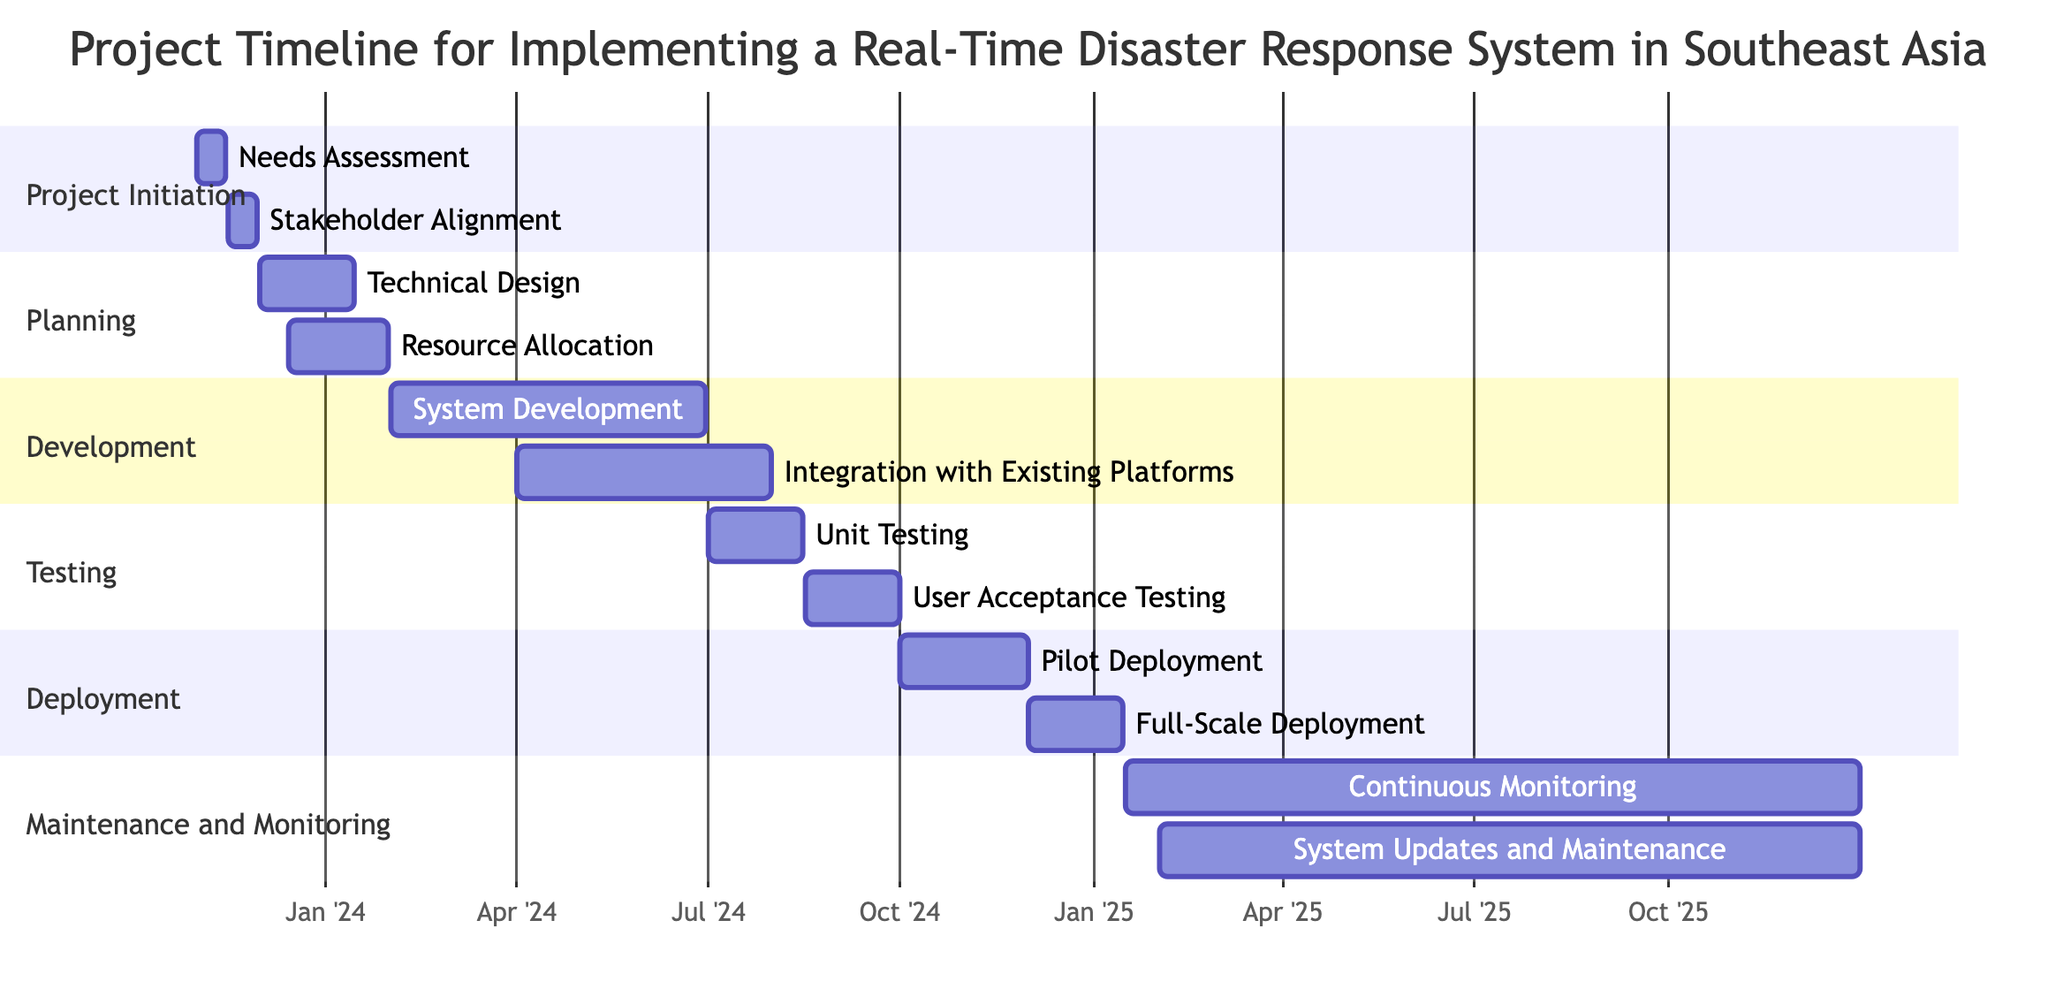What are the start and end dates for the "Needs Assessment" task? The "Needs Assessment" task starts on 2023-11-01 and ends on 2023-11-15, which can be directly identified in the diagram's "Project Initiation" section.
Answer: 2023-11-01 to 2023-11-15 How many tasks are there in the "Development" phase? The "Development" phase contains two tasks: "System Development" and "Integration with Existing Platforms," as shown in the corresponding section of the diagram.
Answer: 2 What is the duration of the "User Acceptance Testing" task? The "User Acceptance Testing" task starts on 2024-08-16 and ends on 2024-09-30. The duration can be calculated as the difference between these two dates, which is 1 month and 14 days, but is also visible directly on the Gantt chart itself.
Answer: 1 month and 14 days Which task overlaps with the "System Development" task? The "Integration with Existing Platforms" task overlaps with "System Development" since it starts on 2024-04-01 while "System Development" is still ongoing until 2024-06-30, as observed in the "Development" section of the diagram.
Answer: Integration with Existing Platforms What is the earliest date of "Pilot Deployment"? The "Pilot Deployment" task begins on 2024-10-01, which is the date clearly indicated at the start of this task in the "Deployment" section of the diagram.
Answer: 2024-10-01 When does the "Continuous Monitoring" phase begin? The "Continuous Monitoring" task starts on 2025-01-16, as stated at the beginning of this task in the "Maintenance and Monitoring" section visible in the Gantt chart.
Answer: 2025-01-16 Which resources are involved in the "Stakeholder Alignment" task? The "Stakeholder Alignment" task involves the "Project Manager," "UN Representatives," and "Local Government Officials," as listed directly under the respective task in the diagram.
Answer: Project Manager, UN Representatives, Local Government Officials What is the total duration of the "Planning" phase? The "Planning" phase includes two tasks: "Technical Design" (from 2023-12-01 to 2024-01-15) and "Resource Allocation" (from 2023-12-15 to 2024-01-31). The phase duration can be calculated by finding the starting date of the earliest task and the ending date of the latest task, which gives a duration from 2023-12-01 to 2024-01-31, totaling about 2 months.
Answer: About 2 months What task follows "Unit Testing" in the Gantt chart? "User Acceptance Testing" follows "Unit Testing" in the sequence, as seen in the "Testing" phase of the diagram, where "User Acceptance Testing" is placed directly after "Unit Testing."
Answer: User Acceptance Testing 